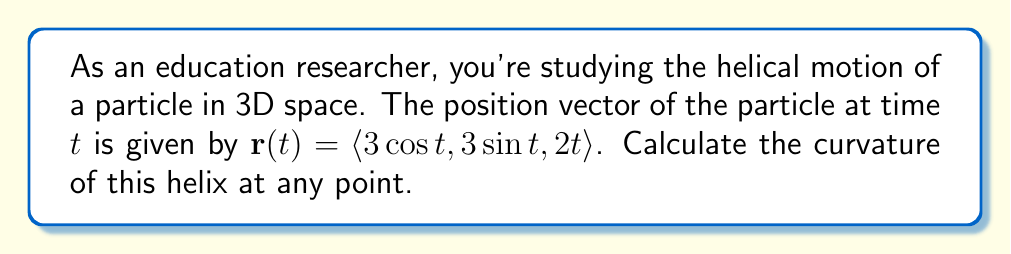Can you solve this math problem? To analyze the curvature of a helix in 3D space, we'll follow these steps:

1) First, recall the formula for curvature:

   $$\kappa = \frac{|\mathbf{r}'(t) \times \mathbf{r}''(t)|}{|\mathbf{r}'(t)|^3}$$

2) We need to find $\mathbf{r}'(t)$ and $\mathbf{r}''(t)$:

   $\mathbf{r}'(t) = \langle -3\sin t, 3\cos t, 2 \rangle$
   $\mathbf{r}''(t) = \langle -3\cos t, -3\sin t, 0 \rangle$

3) Now, let's calculate $\mathbf{r}'(t) \times \mathbf{r}''(t)$:

   $$\begin{vmatrix} 
   \mathbf{i} & \mathbf{j} & \mathbf{k} \\
   -3\sin t & 3\cos t & 2 \\
   -3\cos t & -3\sin t & 0
   \end{vmatrix}$$

   $= \langle -6\sin t, -6\cos t, -9\sin^2 t - 9\cos^2 t \rangle$
   $= \langle -6\sin t, -6\cos t, -9 \rangle$

4) The magnitude of this cross product is:

   $|\mathbf{r}'(t) \times \mathbf{r}''(t)| = \sqrt{36\sin^2 t + 36\cos^2 t + 81} = \sqrt{117}$

5) Next, we need $|\mathbf{r}'(t)|^3$:

   $|\mathbf{r}'(t)| = \sqrt{9\sin^2 t + 9\cos^2 t + 4} = \sqrt{13}$

   $|\mathbf{r}'(t)|^3 = (\sqrt{13})^3 = 13\sqrt{13}$

6) Now we can substitute into the curvature formula:

   $$\kappa = \frac{\sqrt{117}}{13\sqrt{13}}$$

This value is constant, which means the curvature of the helix is the same at all points.
Answer: The curvature of the helix is $\kappa = \frac{\sqrt{117}}{13\sqrt{13}}$, which is constant for all points on the curve. 